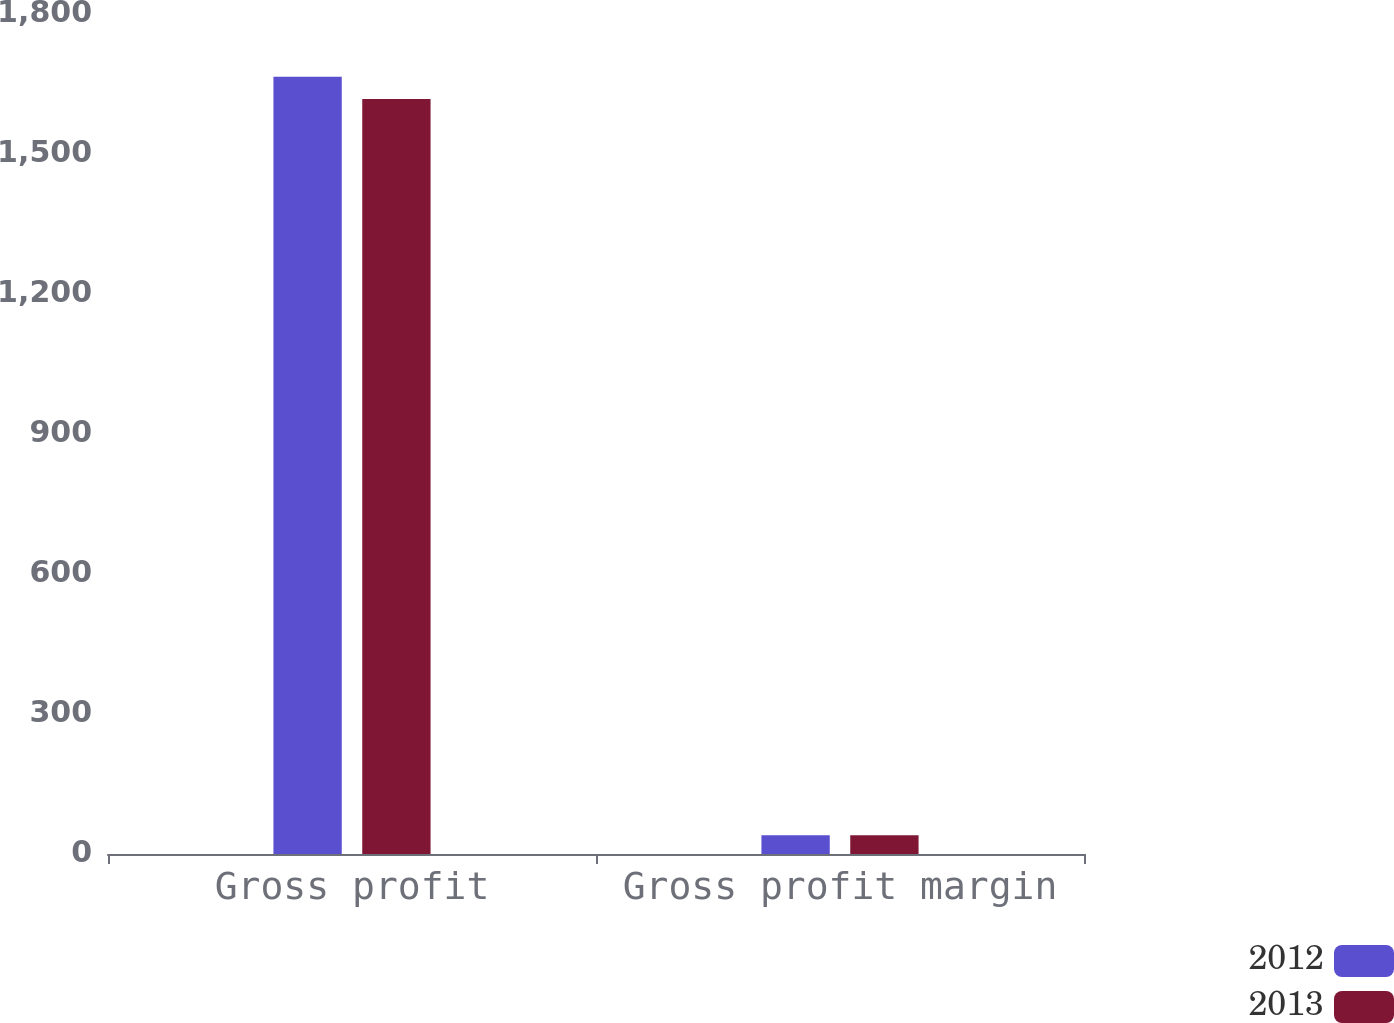<chart> <loc_0><loc_0><loc_500><loc_500><stacked_bar_chart><ecel><fcel>Gross profit<fcel>Gross profit margin<nl><fcel>2012<fcel>1665.8<fcel>40.4<nl><fcel>2013<fcel>1617.8<fcel>40.3<nl></chart> 